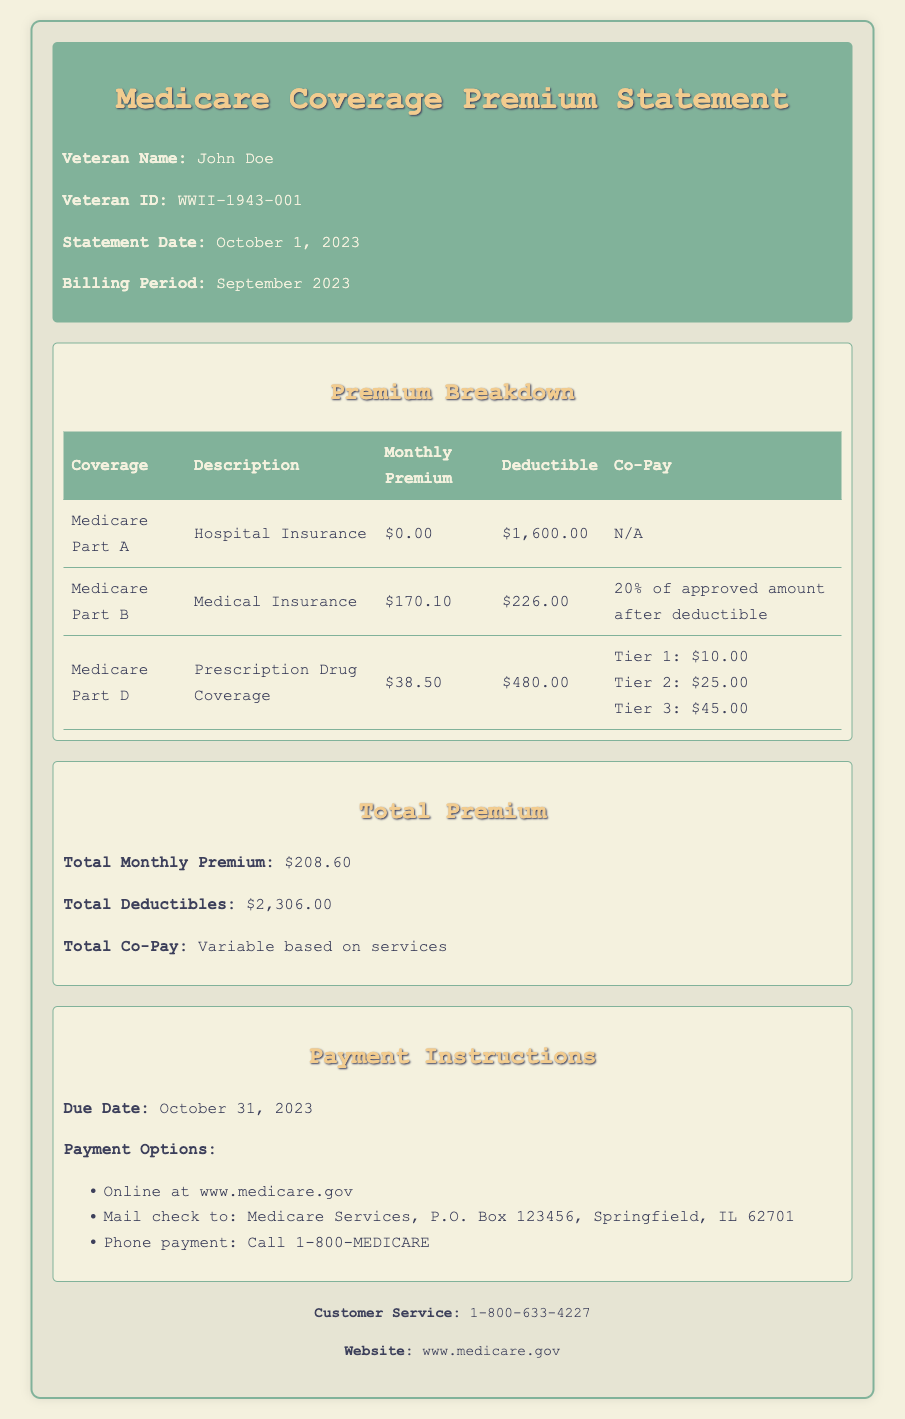What is the due date for payment? The due date for payment is specified in the document under payment instructions as October 31, 2023.
Answer: October 31, 2023 What is the monthly premium for Medicare Part B? The document lists the monthly premium for Medicare Part B in the premium breakdown section as $170.10.
Answer: $170.10 What is the deductible for Medicare Part D? The deductible for Medicare Part D is explicitly stated in the premium breakdown table as $480.00.
Answer: $480.00 What is the total monthly premium for all Medicare coverage? The total monthly premium can be found in the total premium section, which adds up to $208.60.
Answer: $208.60 How much is the co-pay for Tier 1 in Medicare Part D? The co-pay for Tier 1 in Medicare Part D is detailed in the premium breakdown table, specifically mentioned as $10.00.
Answer: $10.00 What is the total deductible amount across all Medicare coverage? The total deductible amount is summarized in the document as $2,306.00.
Answer: $2,306.00 What are the options for making a payment? The payment options are listed under payment instructions and include online payment, mailing a check, or phone payment.
Answer: Online, Mail, Phone Who is the customer service contact? The customer service contact information is mentioned at the bottom of the document as 1-800-633-4227.
Answer: 1-800-633-4227 What coverage does Medicare Part A provide? The document describes Medicare Part A as providing Hospital Insurance.
Answer: Hospital Insurance 